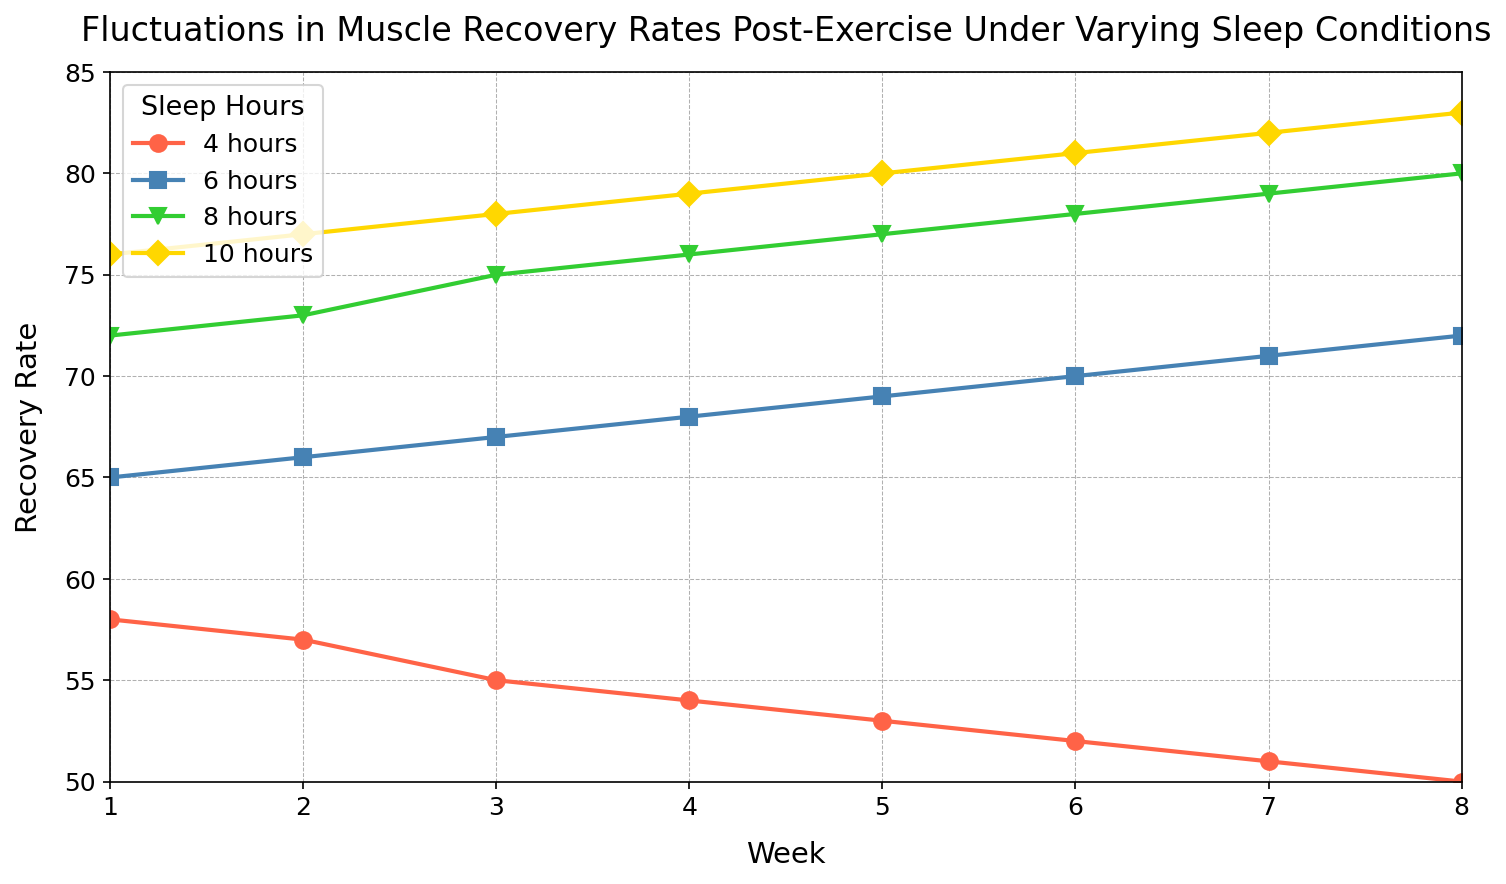Which sleep condition shows the highest muscle recovery rate in Week 3? In Week 3, we observe the lines on the chart related to different sleep conditions. The line for 10 hours of sleep has the highest position on the y-axis in Week 3, corresponding to a muscle recovery rate of 78.
Answer: 10 hours What is the difference in recovery rates between 4 hours and 8 hours of sleep during Week 5? We look at the recovery rates for 4 hours and 8 hours of sleep in Week 5, which are 53 and 77 respectively. The difference is 77 - 53.
Answer: 24 On average, how does the recovery rate change for athletes getting 6 hours of sleep from Week 1 to Week 8? We find the recovery rates for 6 hours of sleep for each week: 65, 66, 67, 68, 69, 70, 71, 72. Sum these values and divide by the number of weeks (8). The average increase per week can then be observed.
Answer: 1 In Week 2, which sleep condition shows the least improvement in recovery rate compared to Week 1? Calculate the differences in recovery rates between Week 2 and Week 1 for each sleep condition. The conditions with the smallest improvement can be identified. For Week 2: 57, 66, 73, 77 and Week 1: 58, 65, 72, 76, differences are -1, 1, 1, 1. The least improvement is seen in the 4 hours condition.
Answer: 4 hours By how much does the recovery rate for 10 hours of sleep improve from Week 4 to Week 8? We identify the recovery rates for 10 hours of sleep in Week 4 and Week 8, which are 79 and 83 respectively. The improvement is 83 - 79.
Answer: 4 Which condition shows a consistent increase in recovery rate over the 8 weeks? We examine the lines for each sleep condition to determine if any show a steady upward trend without any dips over the weeks. The line for 10 hours of sleep shows a consistent increase.
Answer: 10 hours How much higher is the recovery rate for 8 hours of sleep compared to 4 hours of sleep in Week 6? Identify the recovery rates for 8 hours and 4 hours of sleep in Week 6, which are 78 and 52 respectively. The difference can be calculated as 78 - 52.
Answer: 26 Compare the recovery rates for 6 hours of sleep between Week 1 and Week 8, and state the percentage increase. Recovery rates for 6 hours of sleep in Week 1 and Week 8 are 65 and 72 respectively. The percentage increase can be calculated using ((72 - 65) / 65) * 100.
Answer: 10.77% Visualize the general trend of recovery rates for all sleep conditions from Week 1 to Week 8. Which condition has the steepest increase? We focus on the slopes of the lines for each sleep condition over the 8 weeks. The line representing 10 hours of sleep has the steepest increase over time.
Answer: 10 hours 